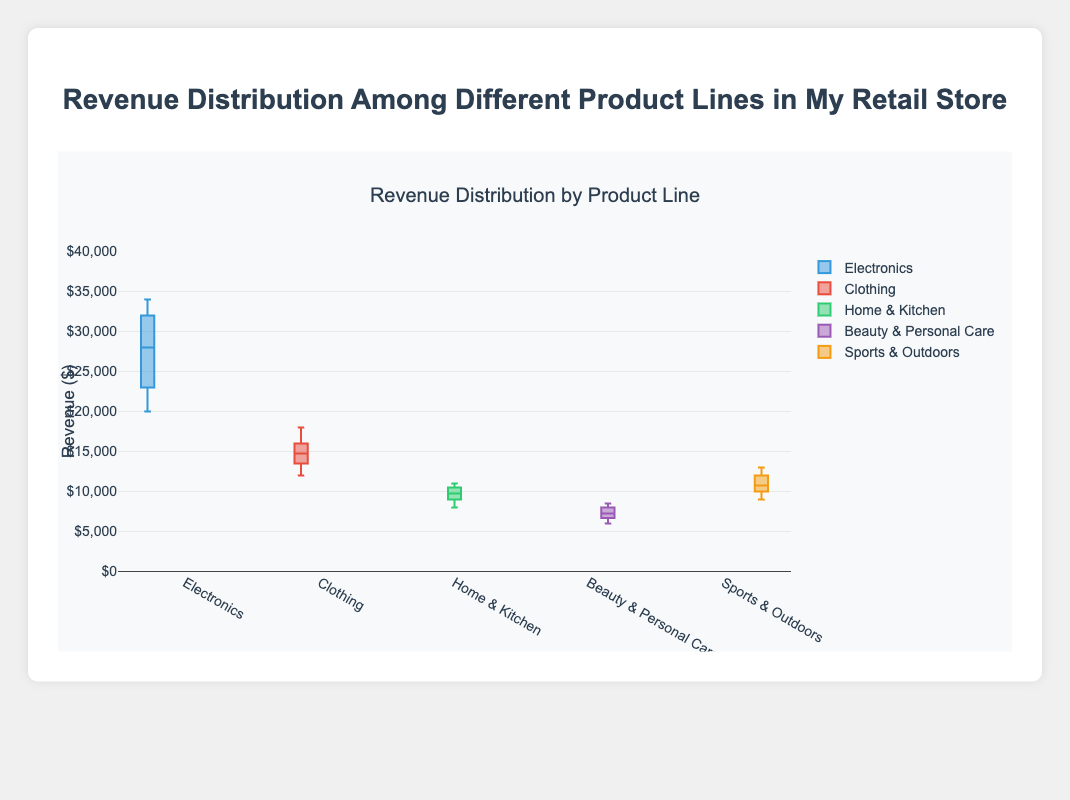what is the title of the box plot? The title of the box plot is typically displayed at the top.
Answer: Revenue Distribution by Product Line How many product lines are compared in the box plot? The box plot shows separate sections for each product line. There are five sections.
Answer: Five Which product line has the highest revenue range? By looking at the vertical length of the boxes, the tallest one indicates the highest revenue range.
Answer: Electronics Which product line has the lowest median revenue? The median is represented by the line inside the box; find the lowest line.
Answer: Beauty & Personal Care How does the revenue range of Clothing compare to Home & Kitchen? Compare the height of the boxes for Clothing and Home & Kitchen. Clothing has a broader range.
Answer: Clothing What is the median revenue for Electronics? The median is the line inside the box of the Electronics section.
Answer: 29,500 Which product line has the smallest interquartile range (IQR)? The interquartile range is the height of the box itself. Identify the shortest box.
Answer: Home & Kitchen How does the maximum revenue for Sports & Outdoors compare to Beauty & Personal Care? Compare the top whiskers of the two boxes to see which one extends higher.
Answer: Sports & Outdoors is higher What's the overall median of all the product lines? Identify all the medians for each product line, then find the median of those values.
Answer: 13,750 Which product line's revenue distribution is the most skewed? Find the box plot with the most asymmetrical shape, or where the whiskers are unequal in length.
Answer: Electronics 